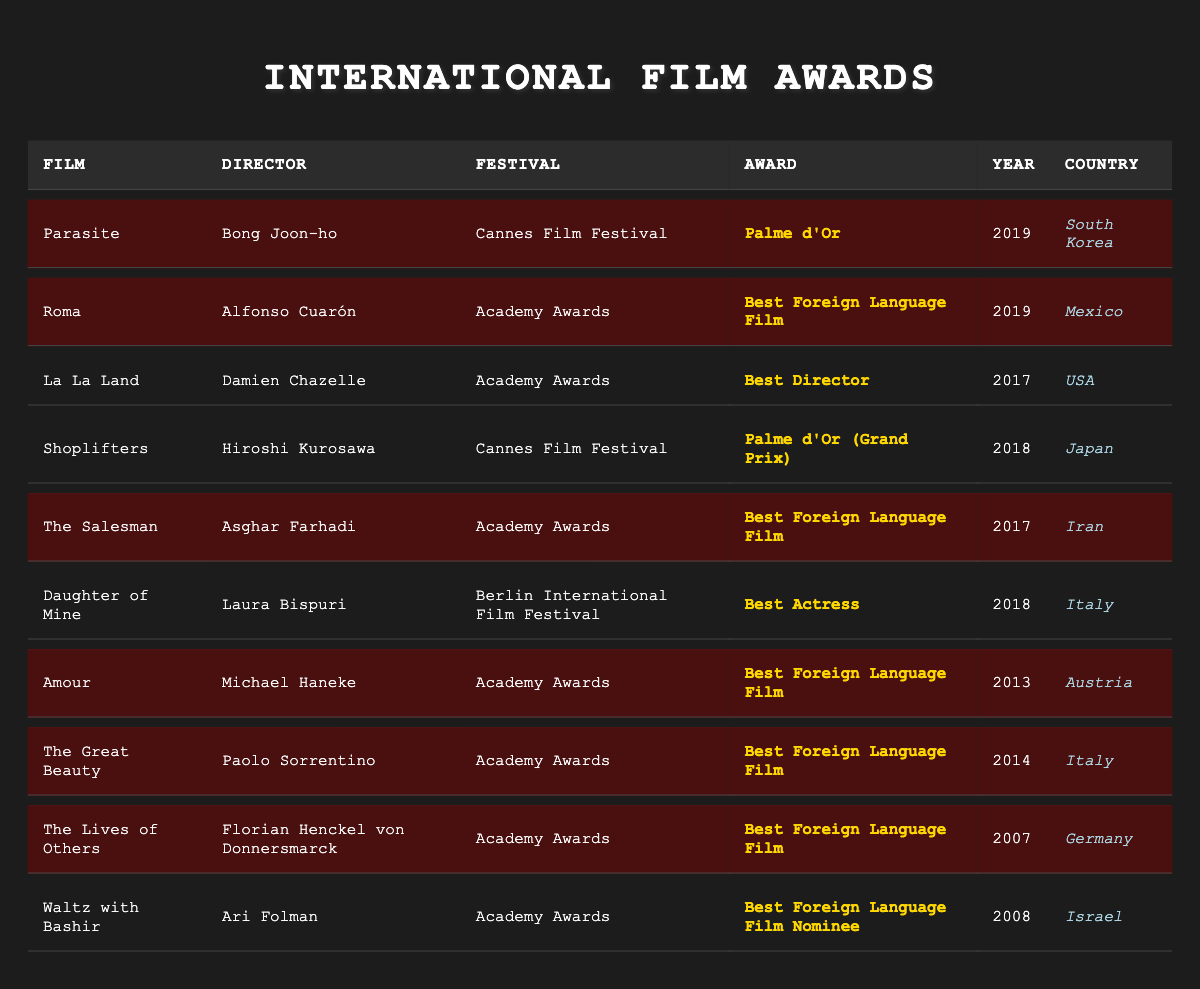What film won the Palme d'Or at the Cannes Film Festival? According to the table, the film that won the Palme d'Or at the Cannes Film Festival is "Parasite," directed by Bong Joon-ho in 2019.
Answer: Parasite Who directed the film "Roma"? The table lists "Roma" as directed by Alfonso Cuarón.
Answer: Alfonso Cuarón How many films listed won the Best Foreign Language Film at the Academy Awards? The table highlights five films that won the Best Foreign Language Film at the Academy Awards: "Roma," "The Salesman," "Amour," "The Great Beauty," and "The Lives of Others."
Answer: Five Which country is associated with the film "The Great Beauty"? The table shows that "The Great Beauty" is associated with Italy.
Answer: Italy Did "Shoplifters" win any awards at the Cannes Film Festival? The table indicates that "Shoplifters" received the Palme d'Or (Grand Prix) but is not highlighted, suggesting it did not win the top award at the festival.
Answer: No List all the films that won major awards in 2019. The films that won major awards in 2019 include "Parasite" (Palme d'Or at Cannes) and "Roma" (Best Foreign Language Film at the Academy Awards).
Answer: Parasite, Roma What is the most recent film on the list to win the Best Foreign Language Film? By examining the years listed, "Roma" in 2019 is the most recent film to win the Best Foreign Language Film.
Answer: Roma Which director has won foreign language film awards for multiple films? The table shows that Asghar Farhadi won for "The Salesman" and has had prior recognition, suggesting he has multiple accolades but is not listed for others here.
Answer: Not enough information Calculate the total number of awards won by highlighted films in the table. The highlighted films that won awards include "Parasite," "Roma," "The Salesman," "Amour," "The Great Beauty," and "The Lives of Others." In total, that makes six awards won by the highlighted films.
Answer: Six Is there any film from South Korea that won an award? The table shows "Parasite," a South Korean film that won the Palme d'Or at the Cannes Film Festival.
Answer: Yes Which film from Germany won an award, and what was it? According to the table, "The Lives of Others" from Germany won the Best Foreign Language Film at the Academy Awards.
Answer: The Lives of Others, Best Foreign Language Film 